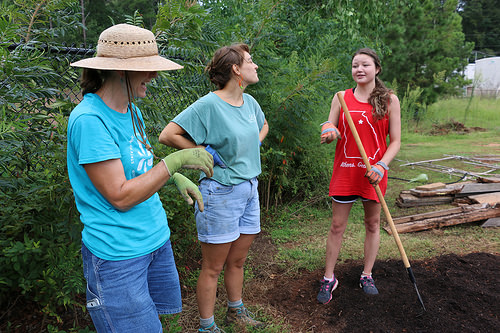<image>
Is the girl to the left of the girl? Yes. From this viewpoint, the girl is positioned to the left side relative to the girl. Is there a hat in front of the woman? No. The hat is not in front of the woman. The spatial positioning shows a different relationship between these objects. 